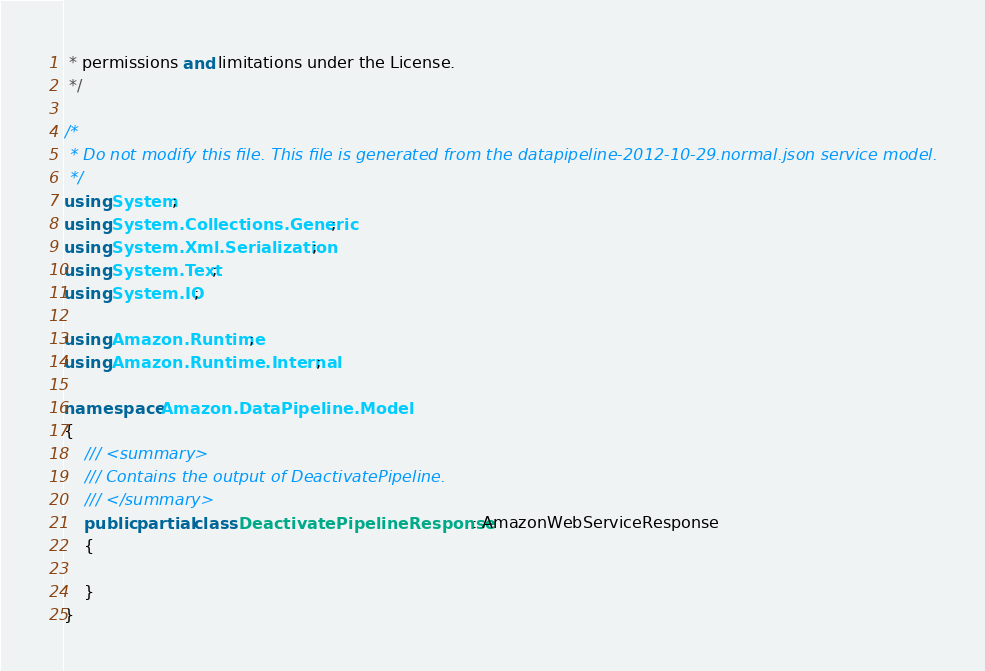Convert code to text. <code><loc_0><loc_0><loc_500><loc_500><_C#_> * permissions and limitations under the License.
 */

/*
 * Do not modify this file. This file is generated from the datapipeline-2012-10-29.normal.json service model.
 */
using System;
using System.Collections.Generic;
using System.Xml.Serialization;
using System.Text;
using System.IO;

using Amazon.Runtime;
using Amazon.Runtime.Internal;

namespace Amazon.DataPipeline.Model
{
    /// <summary>
    /// Contains the output of DeactivatePipeline.
    /// </summary>
    public partial class DeactivatePipelineResponse : AmazonWebServiceResponse
    {

    }
}</code> 